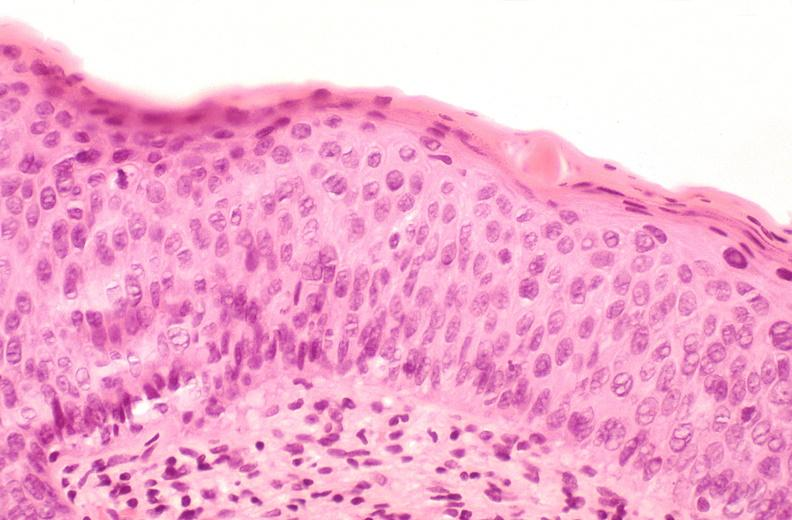what is present?
Answer the question using a single word or phrase. Female reproductive 